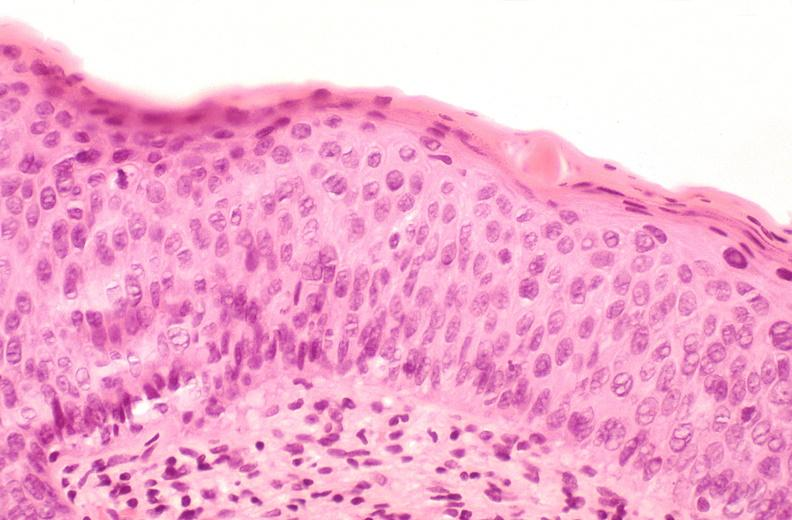what is present?
Answer the question using a single word or phrase. Female reproductive 